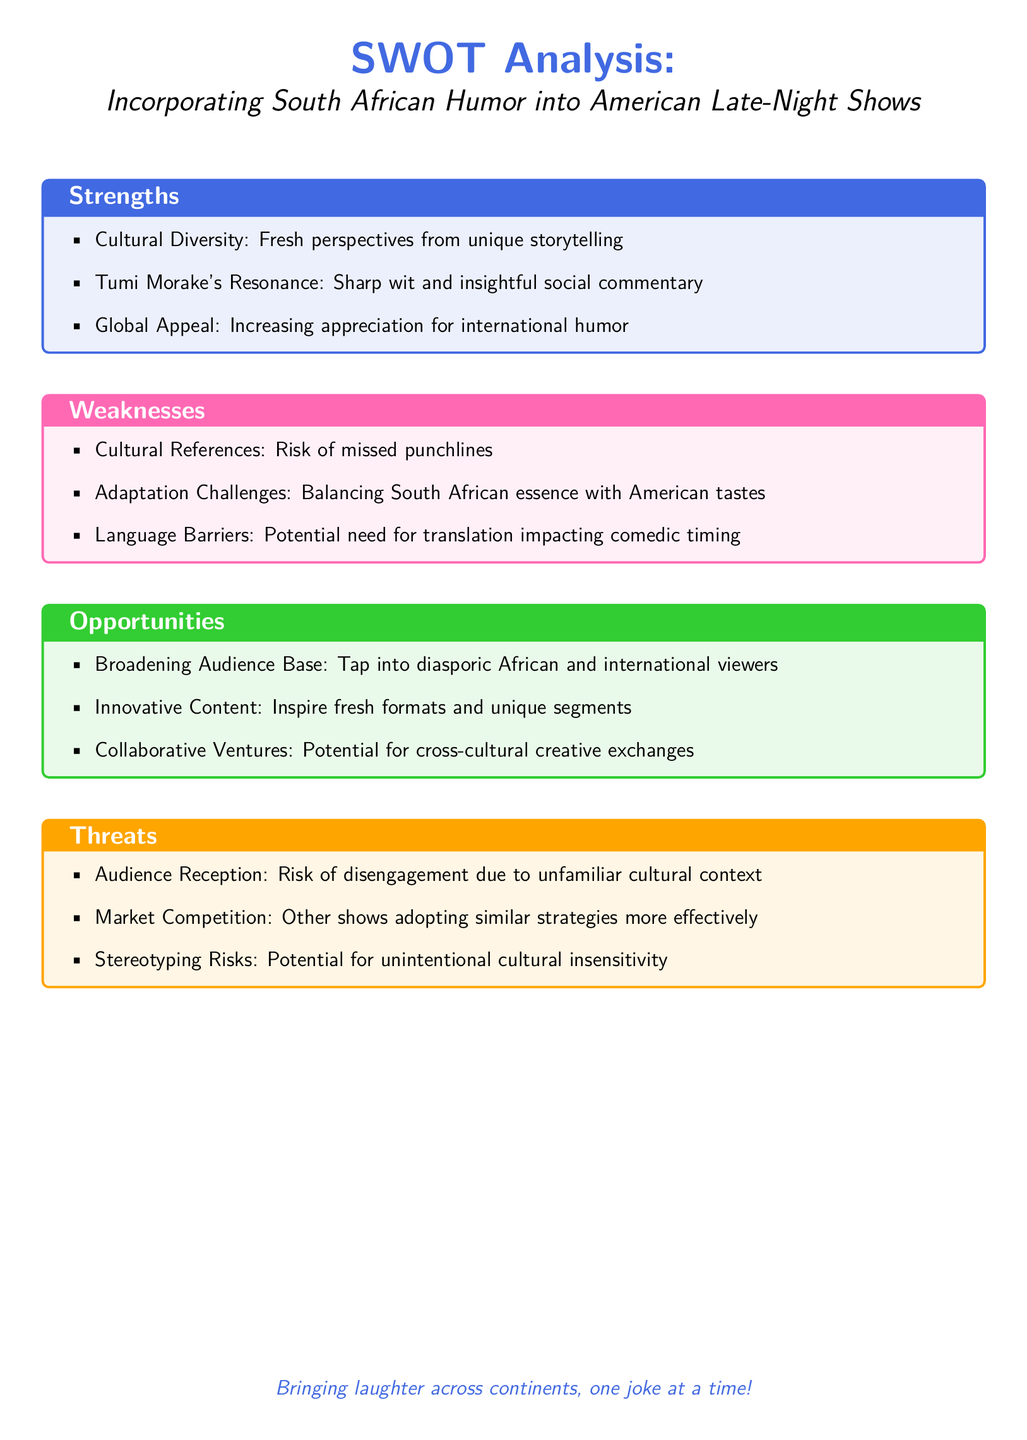What are the strengths listed? The strengths are detailed in the first section of the SWOT analysis, which includes cultural diversity, Tumi Morake's resonance, and global appeal.
Answer: Cultural Diversity, Tumi Morake's Resonance, Global Appeal What is one weakness related to cultural references? One specific weakness is the risk of missed punchlines, which can arise from cultural references that may not resonate with the audience.
Answer: Risk of missed punchlines What opportunity is mentioned for broadening the audience base? The analysis states that tapping into the diasporic African and international viewers represents an opportunity for broadening the audience base.
Answer: Tap into diasporic African and international viewers What threat relates to audience reception? The document mentions the risk of disengagement due to an unfamiliar cultural context as a threat concerning audience reception.
Answer: Risk of disengagement due to unfamiliar cultural context What cultural figure is highlighted for their humor? Tumi Morake is specifically referenced in the document for her sharp wit and insightful social commentary.
Answer: Tumi Morake What is the documented potential impact of language barriers? The potential impact of language barriers mentioned in the document may affect comedic timing, indicating a challenge in adaptation.
Answer: Potential need for translation impacting comedic timing What type of cultural exchange is mentioned as an opportunity? The SWOT analysis highlights the potential for cross-cultural creative exchanges as an opportunity.
Answer: Cross-cultural creative exchanges What color is used for the "Opportunities" section? The document defines the "Opportunities" section with the funny green color.
Answer: Funny green How many main sections are in the SWOT analysis? The SWOT analysis consists of four main sections: Strengths, Weaknesses, Opportunities, and Threats.
Answer: Four 